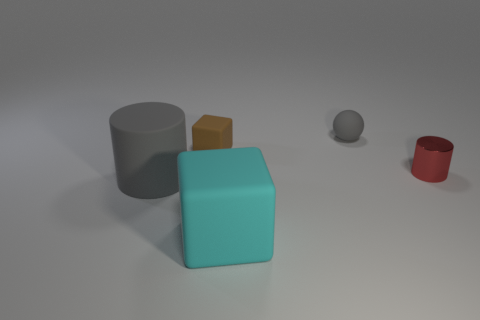Can you tell me the shapes and colors of the objects in the image? Certainly. There are four objects in the image: a gray cylinder, a teal cube, a small yellow cube, and a red cylinder. 